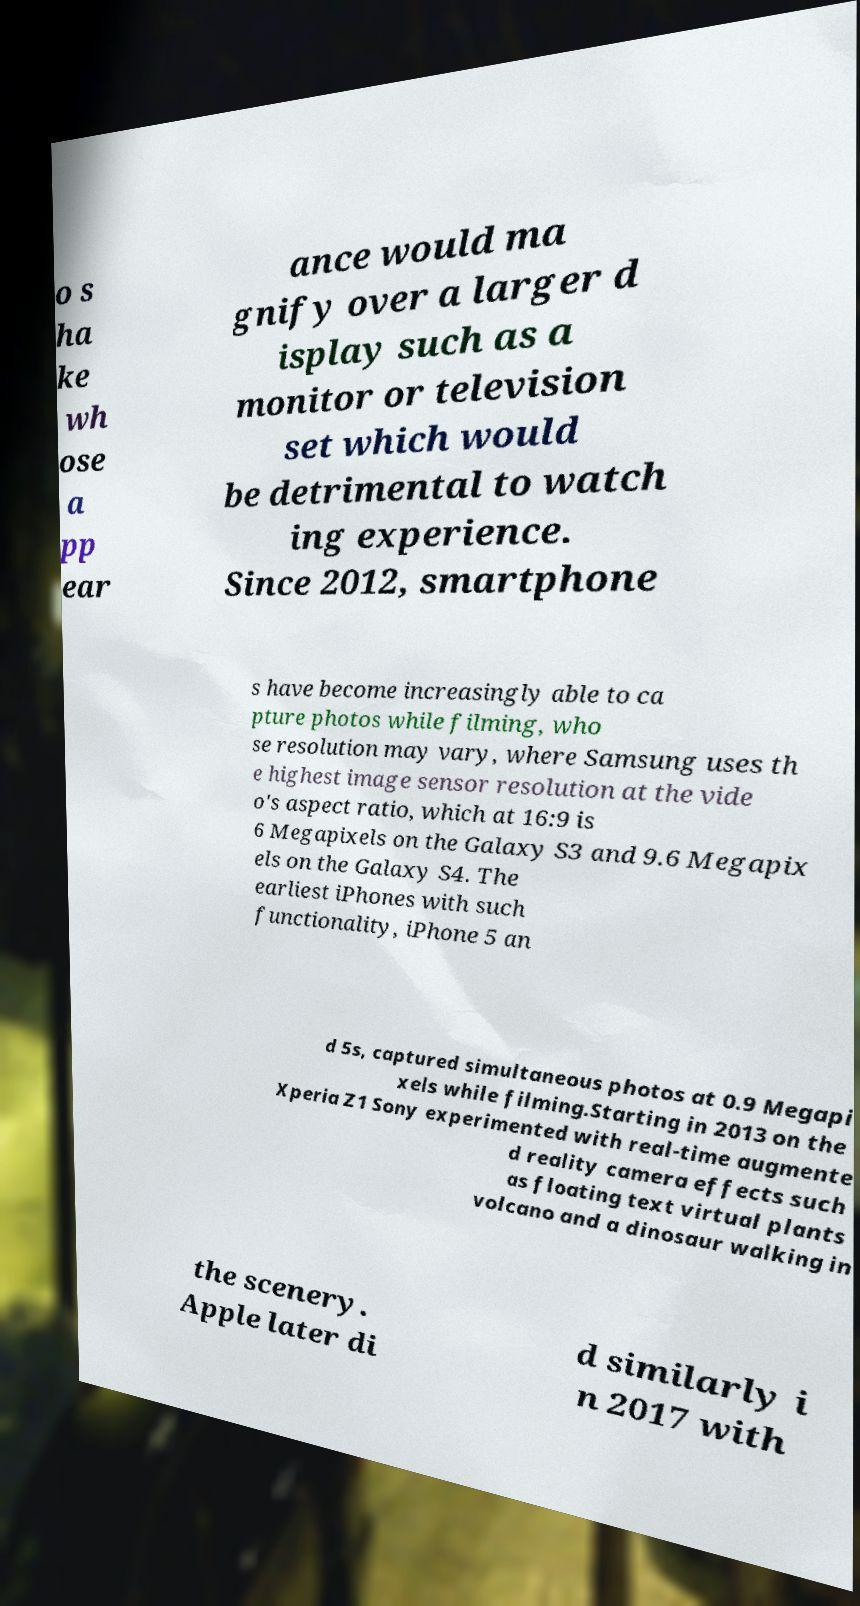Could you extract and type out the text from this image? o s ha ke wh ose a pp ear ance would ma gnify over a larger d isplay such as a monitor or television set which would be detrimental to watch ing experience. Since 2012, smartphone s have become increasingly able to ca pture photos while filming, who se resolution may vary, where Samsung uses th e highest image sensor resolution at the vide o's aspect ratio, which at 16:9 is 6 Megapixels on the Galaxy S3 and 9.6 Megapix els on the Galaxy S4. The earliest iPhones with such functionality, iPhone 5 an d 5s, captured simultaneous photos at 0.9 Megapi xels while filming.Starting in 2013 on the Xperia Z1 Sony experimented with real-time augmente d reality camera effects such as floating text virtual plants volcano and a dinosaur walking in the scenery. Apple later di d similarly i n 2017 with 